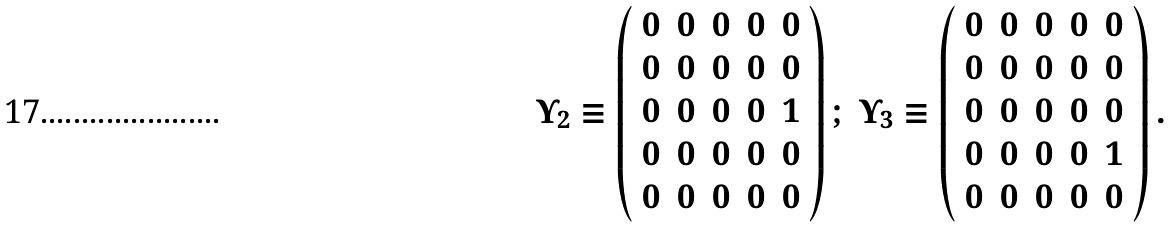<formula> <loc_0><loc_0><loc_500><loc_500>\begin{array} { c c } \Upsilon _ { 2 } \equiv \left ( \begin{array} { c c c c c } 0 & 0 & 0 & 0 & 0 \\ 0 & 0 & 0 & 0 & 0 \\ 0 & 0 & 0 & 0 & 1 \\ 0 & 0 & 0 & 0 & 0 \\ 0 & 0 & 0 & 0 & 0 \end{array} \right ) ; & \Upsilon _ { 3 } \equiv \left ( \begin{array} { c c c c c } 0 & 0 & 0 & 0 & 0 \\ 0 & 0 & 0 & 0 & 0 \\ 0 & 0 & 0 & 0 & 0 \\ 0 & 0 & 0 & 0 & 1 \\ 0 & 0 & 0 & 0 & 0 \end{array} \right ) . \end{array}</formula> 